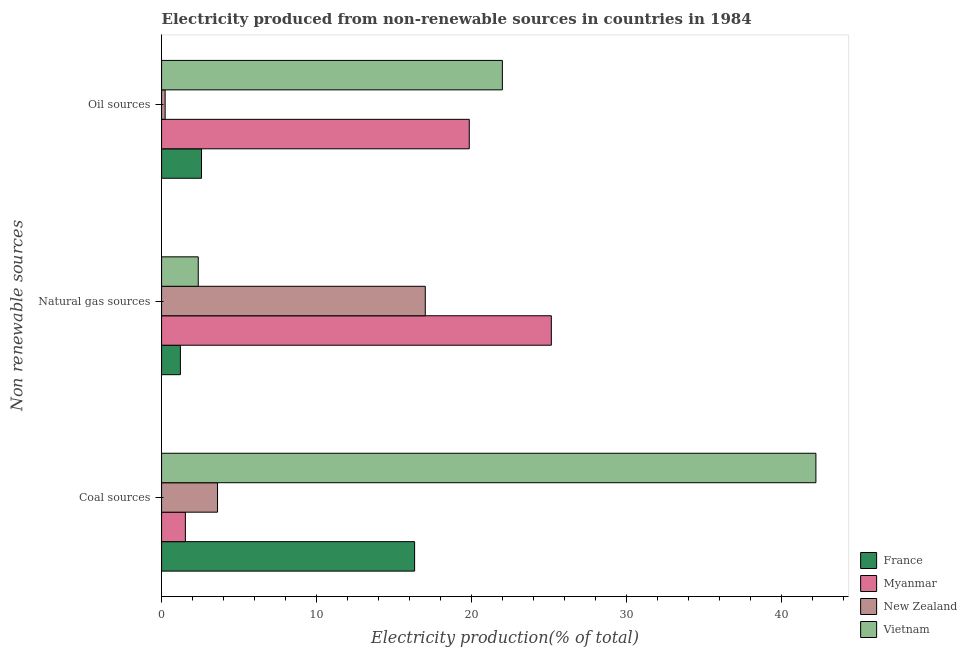How many different coloured bars are there?
Ensure brevity in your answer.  4. Are the number of bars per tick equal to the number of legend labels?
Ensure brevity in your answer.  Yes. Are the number of bars on each tick of the Y-axis equal?
Give a very brief answer. Yes. How many bars are there on the 2nd tick from the top?
Ensure brevity in your answer.  4. What is the label of the 3rd group of bars from the top?
Provide a short and direct response. Coal sources. What is the percentage of electricity produced by coal in Myanmar?
Your answer should be very brief. 1.53. Across all countries, what is the maximum percentage of electricity produced by coal?
Give a very brief answer. 42.19. Across all countries, what is the minimum percentage of electricity produced by natural gas?
Keep it short and to the point. 1.21. In which country was the percentage of electricity produced by natural gas maximum?
Make the answer very short. Myanmar. In which country was the percentage of electricity produced by coal minimum?
Your response must be concise. Myanmar. What is the total percentage of electricity produced by natural gas in the graph?
Provide a short and direct response. 45.72. What is the difference between the percentage of electricity produced by oil sources in New Zealand and that in France?
Offer a terse response. -2.35. What is the difference between the percentage of electricity produced by coal in New Zealand and the percentage of electricity produced by natural gas in Myanmar?
Offer a terse response. -21.52. What is the average percentage of electricity produced by oil sources per country?
Keep it short and to the point. 11.16. What is the difference between the percentage of electricity produced by coal and percentage of electricity produced by natural gas in France?
Offer a very short reply. 15.1. In how many countries, is the percentage of electricity produced by natural gas greater than 16 %?
Keep it short and to the point. 2. What is the ratio of the percentage of electricity produced by coal in France to that in Vietnam?
Make the answer very short. 0.39. Is the percentage of electricity produced by coal in Vietnam less than that in France?
Offer a terse response. No. What is the difference between the highest and the second highest percentage of electricity produced by oil sources?
Offer a terse response. 2.13. What is the difference between the highest and the lowest percentage of electricity produced by natural gas?
Keep it short and to the point. 23.92. Is the sum of the percentage of electricity produced by natural gas in Myanmar and New Zealand greater than the maximum percentage of electricity produced by coal across all countries?
Provide a short and direct response. No. What does the 1st bar from the top in Natural gas sources represents?
Keep it short and to the point. Vietnam. What does the 3rd bar from the bottom in Natural gas sources represents?
Ensure brevity in your answer.  New Zealand. How many bars are there?
Your response must be concise. 12. How many countries are there in the graph?
Your answer should be very brief. 4. What is the difference between two consecutive major ticks on the X-axis?
Keep it short and to the point. 10. Are the values on the major ticks of X-axis written in scientific E-notation?
Make the answer very short. No. Does the graph contain any zero values?
Ensure brevity in your answer.  No. How are the legend labels stacked?
Offer a terse response. Vertical. What is the title of the graph?
Provide a short and direct response. Electricity produced from non-renewable sources in countries in 1984. What is the label or title of the X-axis?
Your answer should be compact. Electricity production(% of total). What is the label or title of the Y-axis?
Offer a very short reply. Non renewable sources. What is the Electricity production(% of total) in France in Coal sources?
Offer a very short reply. 16.32. What is the Electricity production(% of total) in Myanmar in Coal sources?
Offer a terse response. 1.53. What is the Electricity production(% of total) of New Zealand in Coal sources?
Your answer should be compact. 3.61. What is the Electricity production(% of total) of Vietnam in Coal sources?
Give a very brief answer. 42.19. What is the Electricity production(% of total) in France in Natural gas sources?
Your response must be concise. 1.21. What is the Electricity production(% of total) of Myanmar in Natural gas sources?
Your response must be concise. 25.13. What is the Electricity production(% of total) in New Zealand in Natural gas sources?
Offer a terse response. 17. What is the Electricity production(% of total) in Vietnam in Natural gas sources?
Ensure brevity in your answer.  2.37. What is the Electricity production(% of total) in France in Oil sources?
Your answer should be compact. 2.58. What is the Electricity production(% of total) of Myanmar in Oil sources?
Keep it short and to the point. 19.84. What is the Electricity production(% of total) in New Zealand in Oil sources?
Offer a terse response. 0.23. What is the Electricity production(% of total) of Vietnam in Oil sources?
Offer a terse response. 21.98. Across all Non renewable sources, what is the maximum Electricity production(% of total) in France?
Offer a very short reply. 16.32. Across all Non renewable sources, what is the maximum Electricity production(% of total) in Myanmar?
Your answer should be very brief. 25.13. Across all Non renewable sources, what is the maximum Electricity production(% of total) of New Zealand?
Your response must be concise. 17. Across all Non renewable sources, what is the maximum Electricity production(% of total) in Vietnam?
Your answer should be compact. 42.19. Across all Non renewable sources, what is the minimum Electricity production(% of total) in France?
Ensure brevity in your answer.  1.21. Across all Non renewable sources, what is the minimum Electricity production(% of total) in Myanmar?
Your response must be concise. 1.53. Across all Non renewable sources, what is the minimum Electricity production(% of total) in New Zealand?
Provide a succinct answer. 0.23. Across all Non renewable sources, what is the minimum Electricity production(% of total) of Vietnam?
Provide a short and direct response. 2.37. What is the total Electricity production(% of total) in France in the graph?
Your answer should be very brief. 20.11. What is the total Electricity production(% of total) in Myanmar in the graph?
Your response must be concise. 46.51. What is the total Electricity production(% of total) in New Zealand in the graph?
Provide a short and direct response. 20.84. What is the total Electricity production(% of total) of Vietnam in the graph?
Your response must be concise. 66.53. What is the difference between the Electricity production(% of total) in France in Coal sources and that in Natural gas sources?
Keep it short and to the point. 15.1. What is the difference between the Electricity production(% of total) of Myanmar in Coal sources and that in Natural gas sources?
Give a very brief answer. -23.6. What is the difference between the Electricity production(% of total) in New Zealand in Coal sources and that in Natural gas sources?
Ensure brevity in your answer.  -13.4. What is the difference between the Electricity production(% of total) in Vietnam in Coal sources and that in Natural gas sources?
Your answer should be compact. 39.83. What is the difference between the Electricity production(% of total) in France in Coal sources and that in Oil sources?
Provide a short and direct response. 13.74. What is the difference between the Electricity production(% of total) in Myanmar in Coal sources and that in Oil sources?
Your response must be concise. -18.31. What is the difference between the Electricity production(% of total) of New Zealand in Coal sources and that in Oil sources?
Make the answer very short. 3.38. What is the difference between the Electricity production(% of total) in Vietnam in Coal sources and that in Oil sources?
Provide a short and direct response. 20.22. What is the difference between the Electricity production(% of total) in France in Natural gas sources and that in Oil sources?
Provide a succinct answer. -1.36. What is the difference between the Electricity production(% of total) of Myanmar in Natural gas sources and that in Oil sources?
Offer a terse response. 5.29. What is the difference between the Electricity production(% of total) of New Zealand in Natural gas sources and that in Oil sources?
Provide a succinct answer. 16.78. What is the difference between the Electricity production(% of total) of Vietnam in Natural gas sources and that in Oil sources?
Your response must be concise. -19.61. What is the difference between the Electricity production(% of total) of France in Coal sources and the Electricity production(% of total) of Myanmar in Natural gas sources?
Ensure brevity in your answer.  -8.82. What is the difference between the Electricity production(% of total) of France in Coal sources and the Electricity production(% of total) of New Zealand in Natural gas sources?
Offer a terse response. -0.69. What is the difference between the Electricity production(% of total) of France in Coal sources and the Electricity production(% of total) of Vietnam in Natural gas sources?
Keep it short and to the point. 13.95. What is the difference between the Electricity production(% of total) of Myanmar in Coal sources and the Electricity production(% of total) of New Zealand in Natural gas sources?
Ensure brevity in your answer.  -15.47. What is the difference between the Electricity production(% of total) in Myanmar in Coal sources and the Electricity production(% of total) in Vietnam in Natural gas sources?
Your answer should be compact. -0.83. What is the difference between the Electricity production(% of total) in New Zealand in Coal sources and the Electricity production(% of total) in Vietnam in Natural gas sources?
Ensure brevity in your answer.  1.24. What is the difference between the Electricity production(% of total) of France in Coal sources and the Electricity production(% of total) of Myanmar in Oil sources?
Give a very brief answer. -3.52. What is the difference between the Electricity production(% of total) of France in Coal sources and the Electricity production(% of total) of New Zealand in Oil sources?
Your answer should be compact. 16.09. What is the difference between the Electricity production(% of total) in France in Coal sources and the Electricity production(% of total) in Vietnam in Oil sources?
Ensure brevity in your answer.  -5.66. What is the difference between the Electricity production(% of total) of Myanmar in Coal sources and the Electricity production(% of total) of New Zealand in Oil sources?
Provide a short and direct response. 1.3. What is the difference between the Electricity production(% of total) of Myanmar in Coal sources and the Electricity production(% of total) of Vietnam in Oil sources?
Keep it short and to the point. -20.44. What is the difference between the Electricity production(% of total) of New Zealand in Coal sources and the Electricity production(% of total) of Vietnam in Oil sources?
Offer a very short reply. -18.37. What is the difference between the Electricity production(% of total) of France in Natural gas sources and the Electricity production(% of total) of Myanmar in Oil sources?
Provide a short and direct response. -18.63. What is the difference between the Electricity production(% of total) in France in Natural gas sources and the Electricity production(% of total) in New Zealand in Oil sources?
Keep it short and to the point. 0.98. What is the difference between the Electricity production(% of total) of France in Natural gas sources and the Electricity production(% of total) of Vietnam in Oil sources?
Ensure brevity in your answer.  -20.76. What is the difference between the Electricity production(% of total) in Myanmar in Natural gas sources and the Electricity production(% of total) in New Zealand in Oil sources?
Your response must be concise. 24.9. What is the difference between the Electricity production(% of total) in Myanmar in Natural gas sources and the Electricity production(% of total) in Vietnam in Oil sources?
Your answer should be very brief. 3.16. What is the difference between the Electricity production(% of total) of New Zealand in Natural gas sources and the Electricity production(% of total) of Vietnam in Oil sources?
Provide a succinct answer. -4.97. What is the average Electricity production(% of total) of France per Non renewable sources?
Provide a succinct answer. 6.7. What is the average Electricity production(% of total) of Myanmar per Non renewable sources?
Give a very brief answer. 15.5. What is the average Electricity production(% of total) in New Zealand per Non renewable sources?
Offer a very short reply. 6.95. What is the average Electricity production(% of total) in Vietnam per Non renewable sources?
Make the answer very short. 22.18. What is the difference between the Electricity production(% of total) of France and Electricity production(% of total) of Myanmar in Coal sources?
Provide a succinct answer. 14.78. What is the difference between the Electricity production(% of total) of France and Electricity production(% of total) of New Zealand in Coal sources?
Provide a succinct answer. 12.71. What is the difference between the Electricity production(% of total) in France and Electricity production(% of total) in Vietnam in Coal sources?
Provide a short and direct response. -25.88. What is the difference between the Electricity production(% of total) in Myanmar and Electricity production(% of total) in New Zealand in Coal sources?
Offer a very short reply. -2.07. What is the difference between the Electricity production(% of total) of Myanmar and Electricity production(% of total) of Vietnam in Coal sources?
Ensure brevity in your answer.  -40.66. What is the difference between the Electricity production(% of total) of New Zealand and Electricity production(% of total) of Vietnam in Coal sources?
Keep it short and to the point. -38.59. What is the difference between the Electricity production(% of total) in France and Electricity production(% of total) in Myanmar in Natural gas sources?
Provide a short and direct response. -23.92. What is the difference between the Electricity production(% of total) of France and Electricity production(% of total) of New Zealand in Natural gas sources?
Give a very brief answer. -15.79. What is the difference between the Electricity production(% of total) in France and Electricity production(% of total) in Vietnam in Natural gas sources?
Your answer should be compact. -1.15. What is the difference between the Electricity production(% of total) of Myanmar and Electricity production(% of total) of New Zealand in Natural gas sources?
Give a very brief answer. 8.13. What is the difference between the Electricity production(% of total) in Myanmar and Electricity production(% of total) in Vietnam in Natural gas sources?
Keep it short and to the point. 22.77. What is the difference between the Electricity production(% of total) in New Zealand and Electricity production(% of total) in Vietnam in Natural gas sources?
Make the answer very short. 14.64. What is the difference between the Electricity production(% of total) of France and Electricity production(% of total) of Myanmar in Oil sources?
Provide a succinct answer. -17.27. What is the difference between the Electricity production(% of total) of France and Electricity production(% of total) of New Zealand in Oil sources?
Your response must be concise. 2.35. What is the difference between the Electricity production(% of total) of France and Electricity production(% of total) of Vietnam in Oil sources?
Provide a short and direct response. -19.4. What is the difference between the Electricity production(% of total) in Myanmar and Electricity production(% of total) in New Zealand in Oil sources?
Give a very brief answer. 19.61. What is the difference between the Electricity production(% of total) in Myanmar and Electricity production(% of total) in Vietnam in Oil sources?
Offer a terse response. -2.13. What is the difference between the Electricity production(% of total) of New Zealand and Electricity production(% of total) of Vietnam in Oil sources?
Keep it short and to the point. -21.75. What is the ratio of the Electricity production(% of total) of France in Coal sources to that in Natural gas sources?
Offer a terse response. 13.44. What is the ratio of the Electricity production(% of total) of Myanmar in Coal sources to that in Natural gas sources?
Your answer should be very brief. 0.06. What is the ratio of the Electricity production(% of total) in New Zealand in Coal sources to that in Natural gas sources?
Your answer should be compact. 0.21. What is the ratio of the Electricity production(% of total) in Vietnam in Coal sources to that in Natural gas sources?
Your answer should be very brief. 17.84. What is the ratio of the Electricity production(% of total) in France in Coal sources to that in Oil sources?
Ensure brevity in your answer.  6.34. What is the ratio of the Electricity production(% of total) in Myanmar in Coal sources to that in Oil sources?
Offer a terse response. 0.08. What is the ratio of the Electricity production(% of total) of New Zealand in Coal sources to that in Oil sources?
Ensure brevity in your answer.  15.71. What is the ratio of the Electricity production(% of total) in Vietnam in Coal sources to that in Oil sources?
Make the answer very short. 1.92. What is the ratio of the Electricity production(% of total) of France in Natural gas sources to that in Oil sources?
Offer a terse response. 0.47. What is the ratio of the Electricity production(% of total) in Myanmar in Natural gas sources to that in Oil sources?
Offer a very short reply. 1.27. What is the ratio of the Electricity production(% of total) in New Zealand in Natural gas sources to that in Oil sources?
Offer a very short reply. 74.06. What is the ratio of the Electricity production(% of total) of Vietnam in Natural gas sources to that in Oil sources?
Your answer should be compact. 0.11. What is the difference between the highest and the second highest Electricity production(% of total) of France?
Offer a terse response. 13.74. What is the difference between the highest and the second highest Electricity production(% of total) in Myanmar?
Your response must be concise. 5.29. What is the difference between the highest and the second highest Electricity production(% of total) of New Zealand?
Give a very brief answer. 13.4. What is the difference between the highest and the second highest Electricity production(% of total) of Vietnam?
Provide a succinct answer. 20.22. What is the difference between the highest and the lowest Electricity production(% of total) of France?
Your response must be concise. 15.1. What is the difference between the highest and the lowest Electricity production(% of total) in Myanmar?
Your answer should be very brief. 23.6. What is the difference between the highest and the lowest Electricity production(% of total) of New Zealand?
Your response must be concise. 16.78. What is the difference between the highest and the lowest Electricity production(% of total) of Vietnam?
Give a very brief answer. 39.83. 